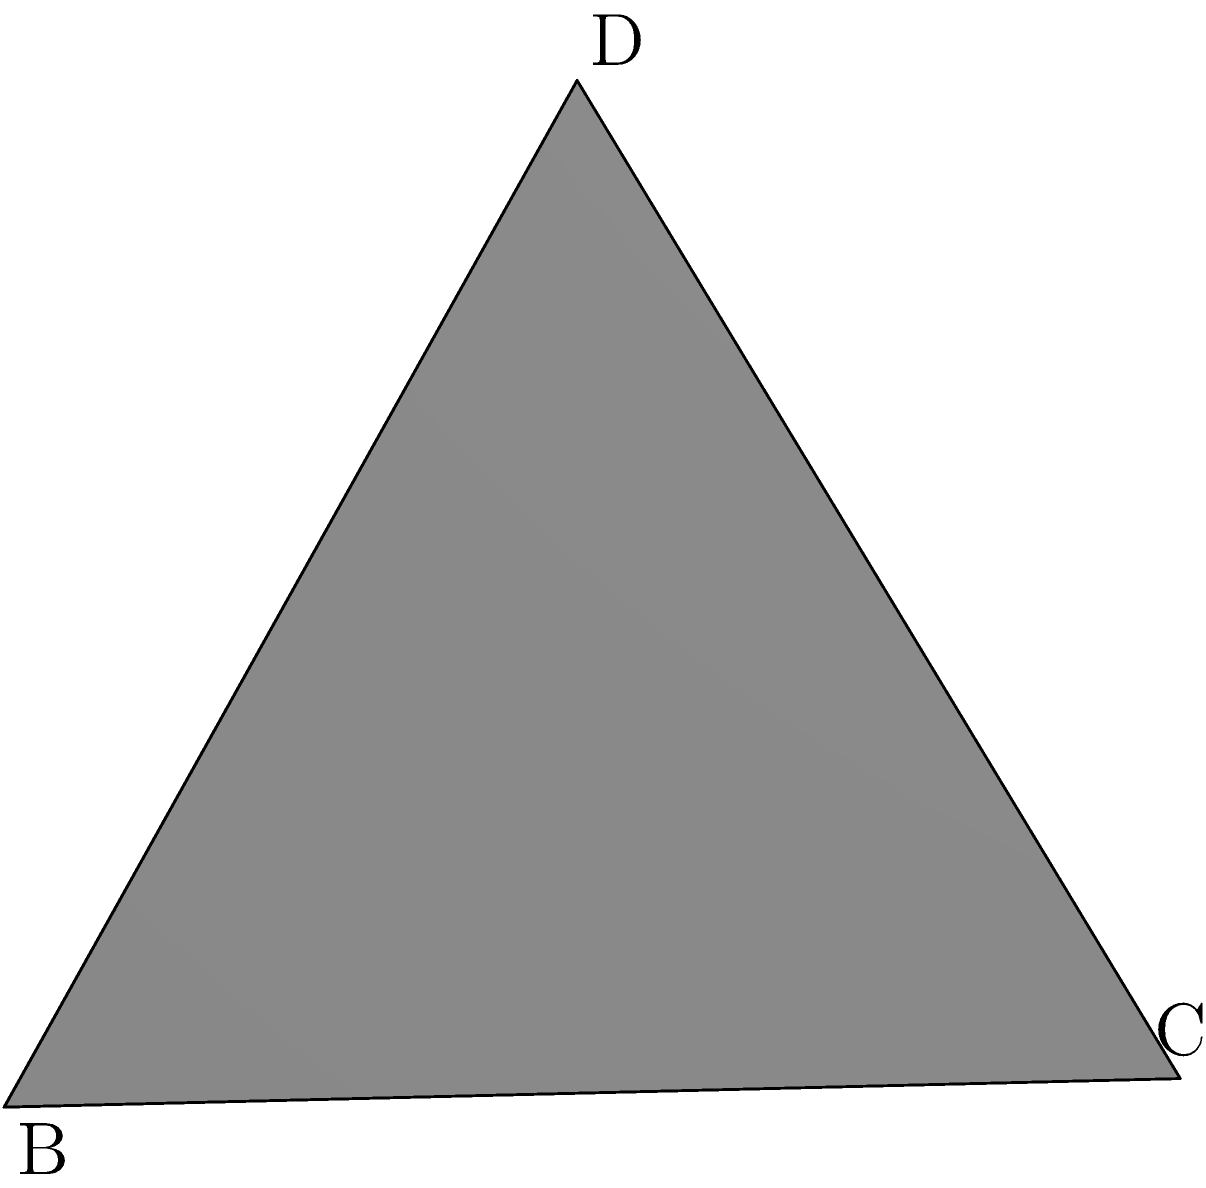In the context of data privacy, consider a regular octahedron as a geometric representation of an encryption key space. Given that the edge length of this octahedron is $a$ units, calculate its surface area. How might this relate to the strength of the encryption in terms of key space size? To solve this problem, we'll follow these steps:

1) First, recall that a regular octahedron consists of 8 equilateral triangles.

2) The area of an equilateral triangle with side length $a$ is:

   $$A_{\text{triangle}} = \frac{\sqrt{3}}{4}a^2$$

3) Since there are 8 such triangles in an octahedron, the total surface area is:

   $$A_{\text{total}} = 8 \cdot \frac{\sqrt{3}}{4}a^2 = 2\sqrt{3}a^2$$

4) Therefore, the surface area of a regular octahedron with edge length $a$ is $2\sqrt{3}a^2$.

Relating this to cryptography:
The surface area of the octahedron can be thought of as representing the size of the key space. A larger surface area (resulting from a larger edge length) would correspond to a larger key space, which generally implies stronger encryption. In cryptography, the size of the key space is crucial for the security of the system, as it determines the number of possible keys and thus the difficulty of a brute-force attack.

However, it's important to note that this is a simplified analogy. In practice, the strength of an encryption system depends on many factors beyond just the size of the key space, including the specific algorithms used, implementation details, and potential vulnerabilities.
Answer: $2\sqrt{3}a^2$ square units 